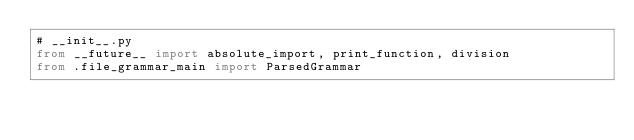<code> <loc_0><loc_0><loc_500><loc_500><_Python_># __init__.py
from __future__ import absolute_import, print_function, division
from .file_grammar_main import ParsedGrammar
</code> 